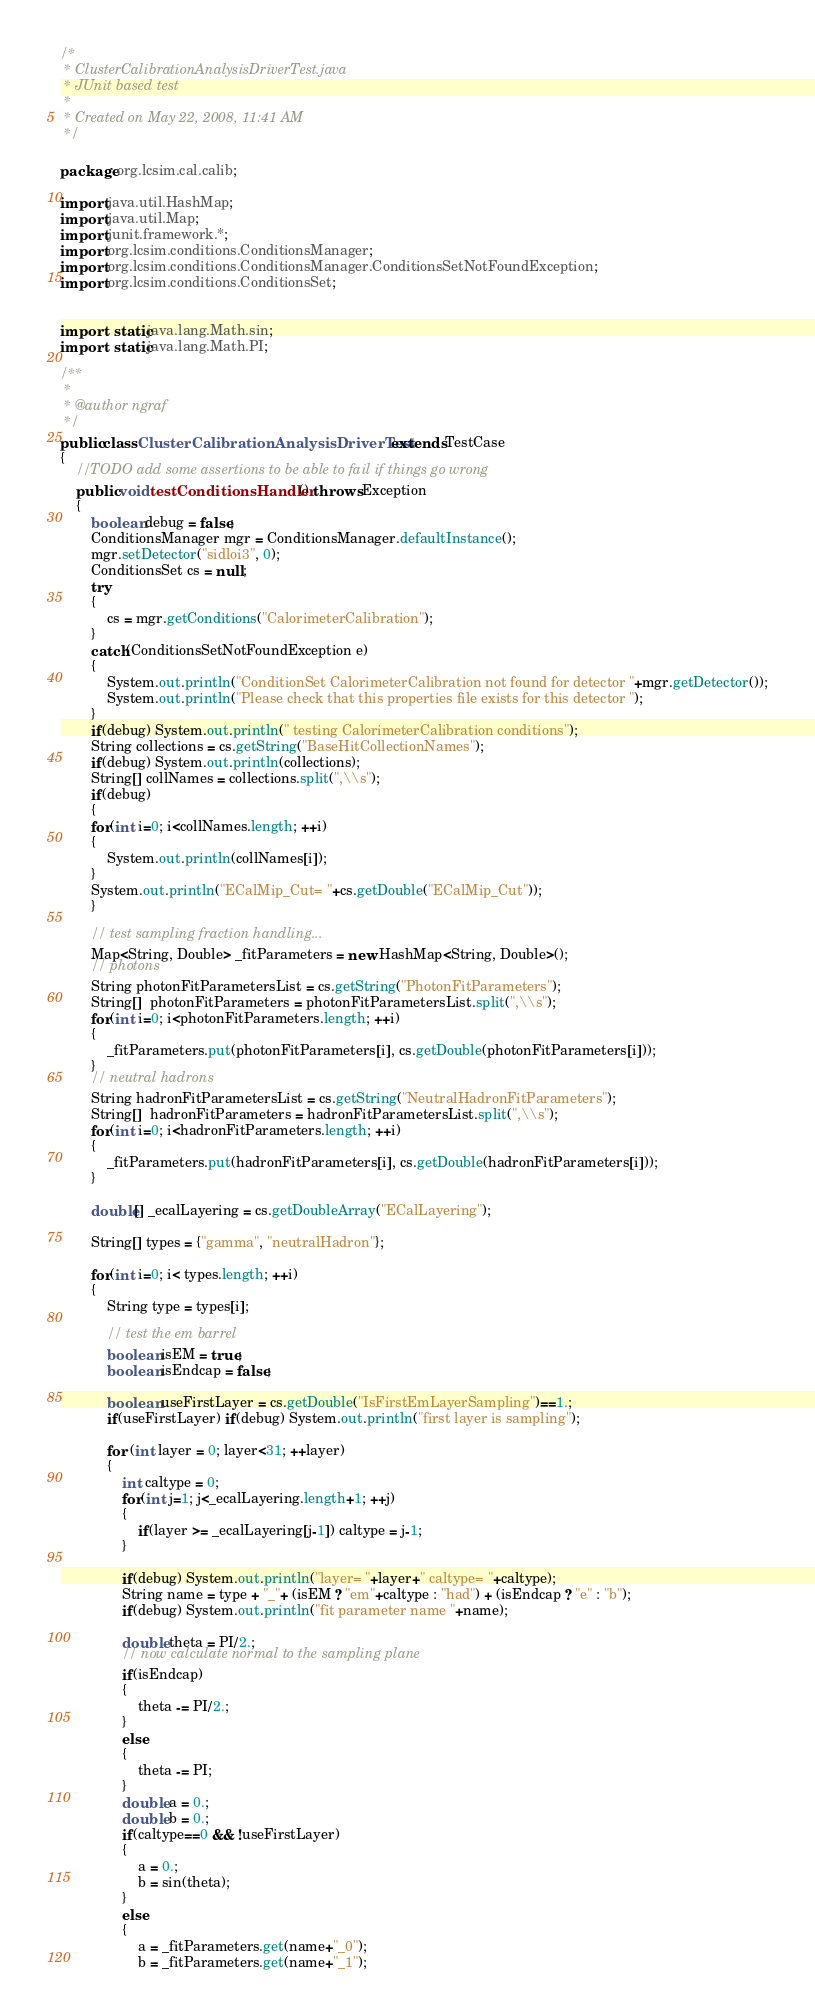<code> <loc_0><loc_0><loc_500><loc_500><_Java_>/*
 * ClusterCalibrationAnalysisDriverTest.java
 * JUnit based test
 *
 * Created on May 22, 2008, 11:41 AM
 */

package org.lcsim.cal.calib;

import java.util.HashMap;
import java.util.Map;
import junit.framework.*;
import org.lcsim.conditions.ConditionsManager;
import org.lcsim.conditions.ConditionsManager.ConditionsSetNotFoundException;
import org.lcsim.conditions.ConditionsSet;


import static java.lang.Math.sin;
import static java.lang.Math.PI;

/**
 *
 * @author ngraf
 */
public class ClusterCalibrationAnalysisDriverTest extends TestCase
{
    //TODO add some assertions to be able to fail if things go wrong
    public void testConditionsHandler() throws Exception
    {
        boolean debug = false;
        ConditionsManager mgr = ConditionsManager.defaultInstance();
        mgr.setDetector("sidloi3", 0);
        ConditionsSet cs = null;
        try
        {
            cs = mgr.getConditions("CalorimeterCalibration");
        }
        catch(ConditionsSetNotFoundException e)
        {
            System.out.println("ConditionSet CalorimeterCalibration not found for detector "+mgr.getDetector());
            System.out.println("Please check that this properties file exists for this detector ");
        }
        if(debug) System.out.println(" testing CalorimeterCalibration conditions");
        String collections = cs.getString("BaseHitCollectionNames");
        if(debug) System.out.println(collections);
        String[] collNames = collections.split(",\\s");
        if(debug)
        {
        for(int i=0; i<collNames.length; ++i)
        {
            System.out.println(collNames[i]);
        }
        System.out.println("ECalMip_Cut= "+cs.getDouble("ECalMip_Cut"));
        }
        
        // test sampling fraction handling...
        Map<String, Double> _fitParameters = new HashMap<String, Double>();
        // photons
        String photonFitParametersList = cs.getString("PhotonFitParameters");
        String[]  photonFitParameters = photonFitParametersList.split(",\\s");
        for(int i=0; i<photonFitParameters.length; ++i)
        {
            _fitParameters.put(photonFitParameters[i], cs.getDouble(photonFitParameters[i]));
        }
        // neutral hadrons
        String hadronFitParametersList = cs.getString("NeutralHadronFitParameters");
        String[]  hadronFitParameters = hadronFitParametersList.split(",\\s");
        for(int i=0; i<hadronFitParameters.length; ++i)
        {
            _fitParameters.put(hadronFitParameters[i], cs.getDouble(hadronFitParameters[i]));
        }
        
        double[] _ecalLayering = cs.getDoubleArray("ECalLayering");
        
        String[] types = {"gamma", "neutralHadron"};
        
        for(int i=0; i< types.length; ++i)
        {
            String type = types[i];
            
            // test the em barrel
            boolean isEM = true;
            boolean isEndcap = false;
            
            boolean useFirstLayer = cs.getDouble("IsFirstEmLayerSampling")==1.;
            if(useFirstLayer) if(debug) System.out.println("first layer is sampling");
            
            for (int layer = 0; layer<31; ++layer)
            {
                int caltype = 0;
                for(int j=1; j<_ecalLayering.length+1; ++j)
                {
                    if(layer >= _ecalLayering[j-1]) caltype = j-1;
                }
                
                if(debug) System.out.println("layer= "+layer+" caltype= "+caltype);
                String name = type + "_"+ (isEM ? "em"+caltype : "had") + (isEndcap ? "e" : "b");
                if(debug) System.out.println("fit parameter name "+name);
                
                double theta = PI/2.;
                // now calculate normal to the sampling plane
                if(isEndcap)
                {
                    theta -= PI/2.;
                }
                else
                {
                    theta -= PI;
                }
                double a = 0.;
                double b = 0.;
                if(caltype==0 && !useFirstLayer)
                {
                    a = 0.;
                    b = sin(theta);
                }
                else
                {
                    a = _fitParameters.get(name+"_0");
                    b = _fitParameters.get(name+"_1");</code> 